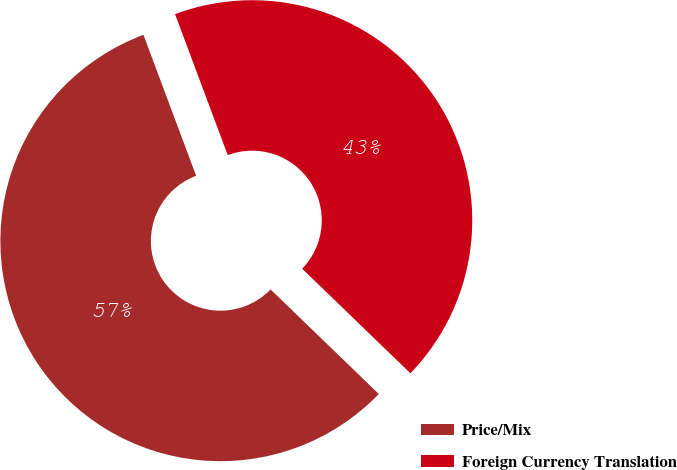Convert chart. <chart><loc_0><loc_0><loc_500><loc_500><pie_chart><fcel>Price/Mix<fcel>Foreign Currency Translation<nl><fcel>57.08%<fcel>42.92%<nl></chart> 